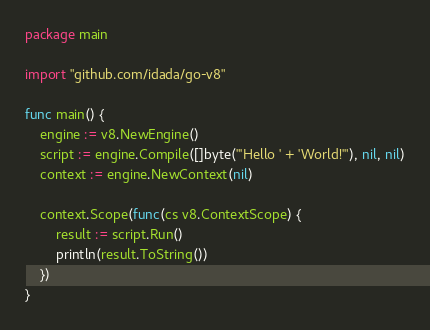<code> <loc_0><loc_0><loc_500><loc_500><_Go_>package main

import "github.com/idada/go-v8"

func main() {
	engine := v8.NewEngine()
	script := engine.Compile([]byte("'Hello ' + 'World!'"), nil, nil)
	context := engine.NewContext(nil)

	context.Scope(func(cs v8.ContextScope) {
		result := script.Run()
		println(result.ToString())
	})
}
</code> 